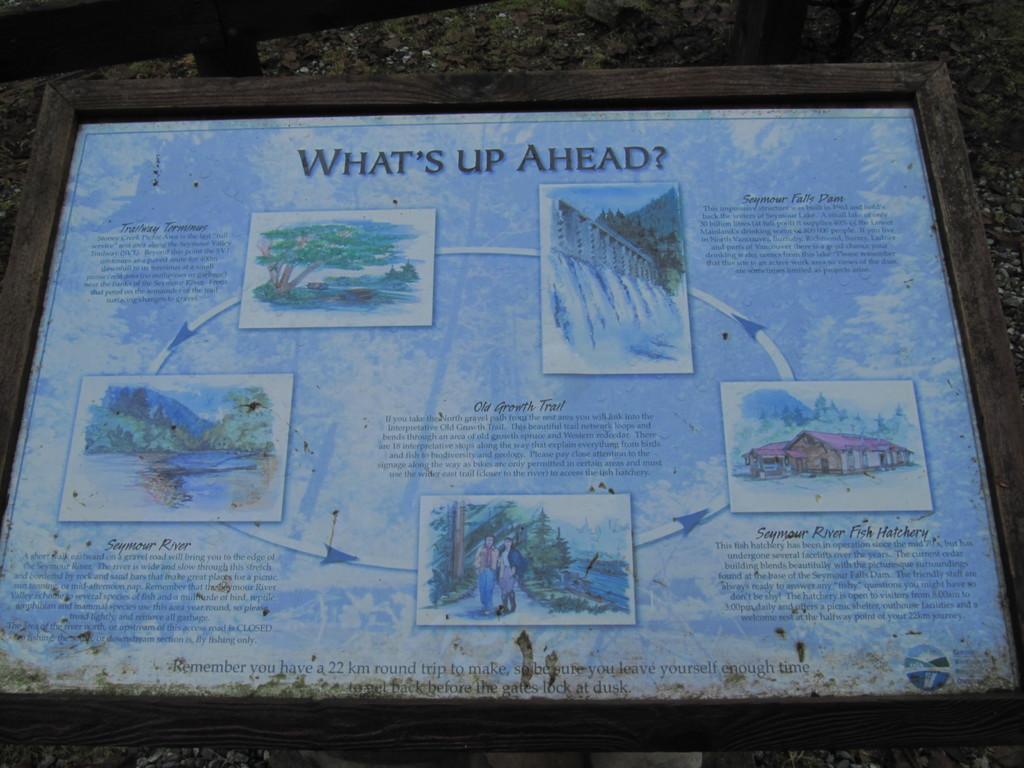How would you summarize this image in a sentence or two? In this image there is a frame with some text and images on it. 